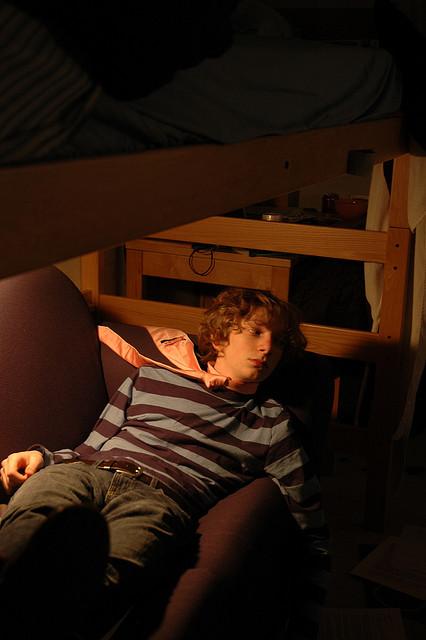Is the boy asleep?
Be succinct. No. What is the boy sleeping on?
Give a very brief answer. Couch. What kind of shirt is this?
Be succinct. Long sleeve. Where are the shoes?
Keep it brief. Feet. How many boys are there?
Keep it brief. 1. 